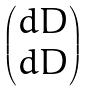Convert formula to latex. <formula><loc_0><loc_0><loc_500><loc_500>\begin{pmatrix} d D \\ d \bar { D } \end{pmatrix}</formula> 